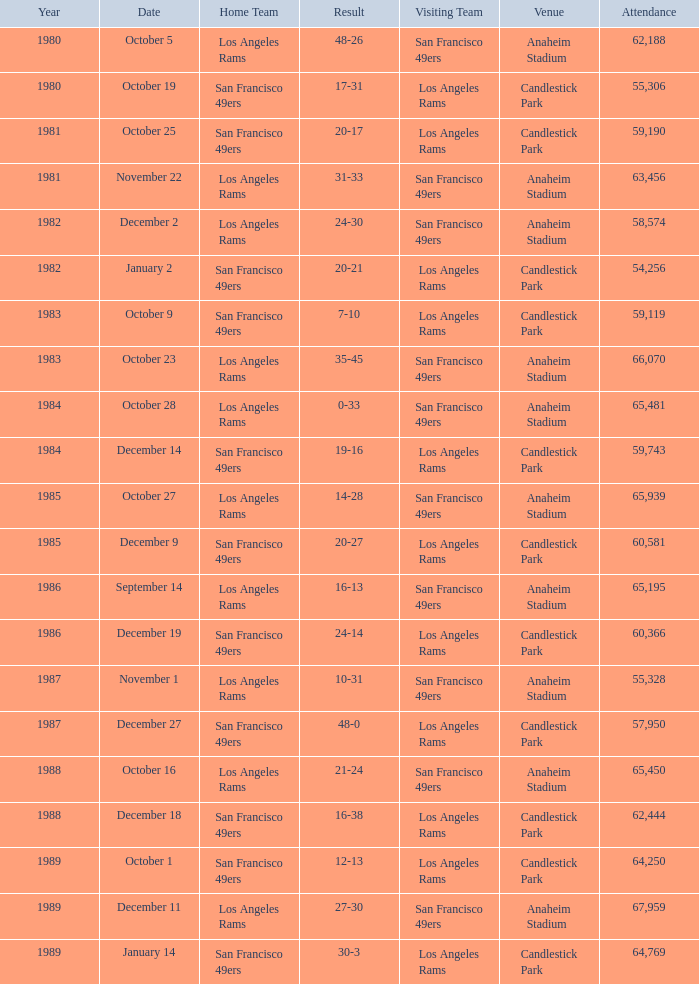What is the cumulative attendance at anaheim stadium after 1983 with a 14-28 outcome? 1.0. 